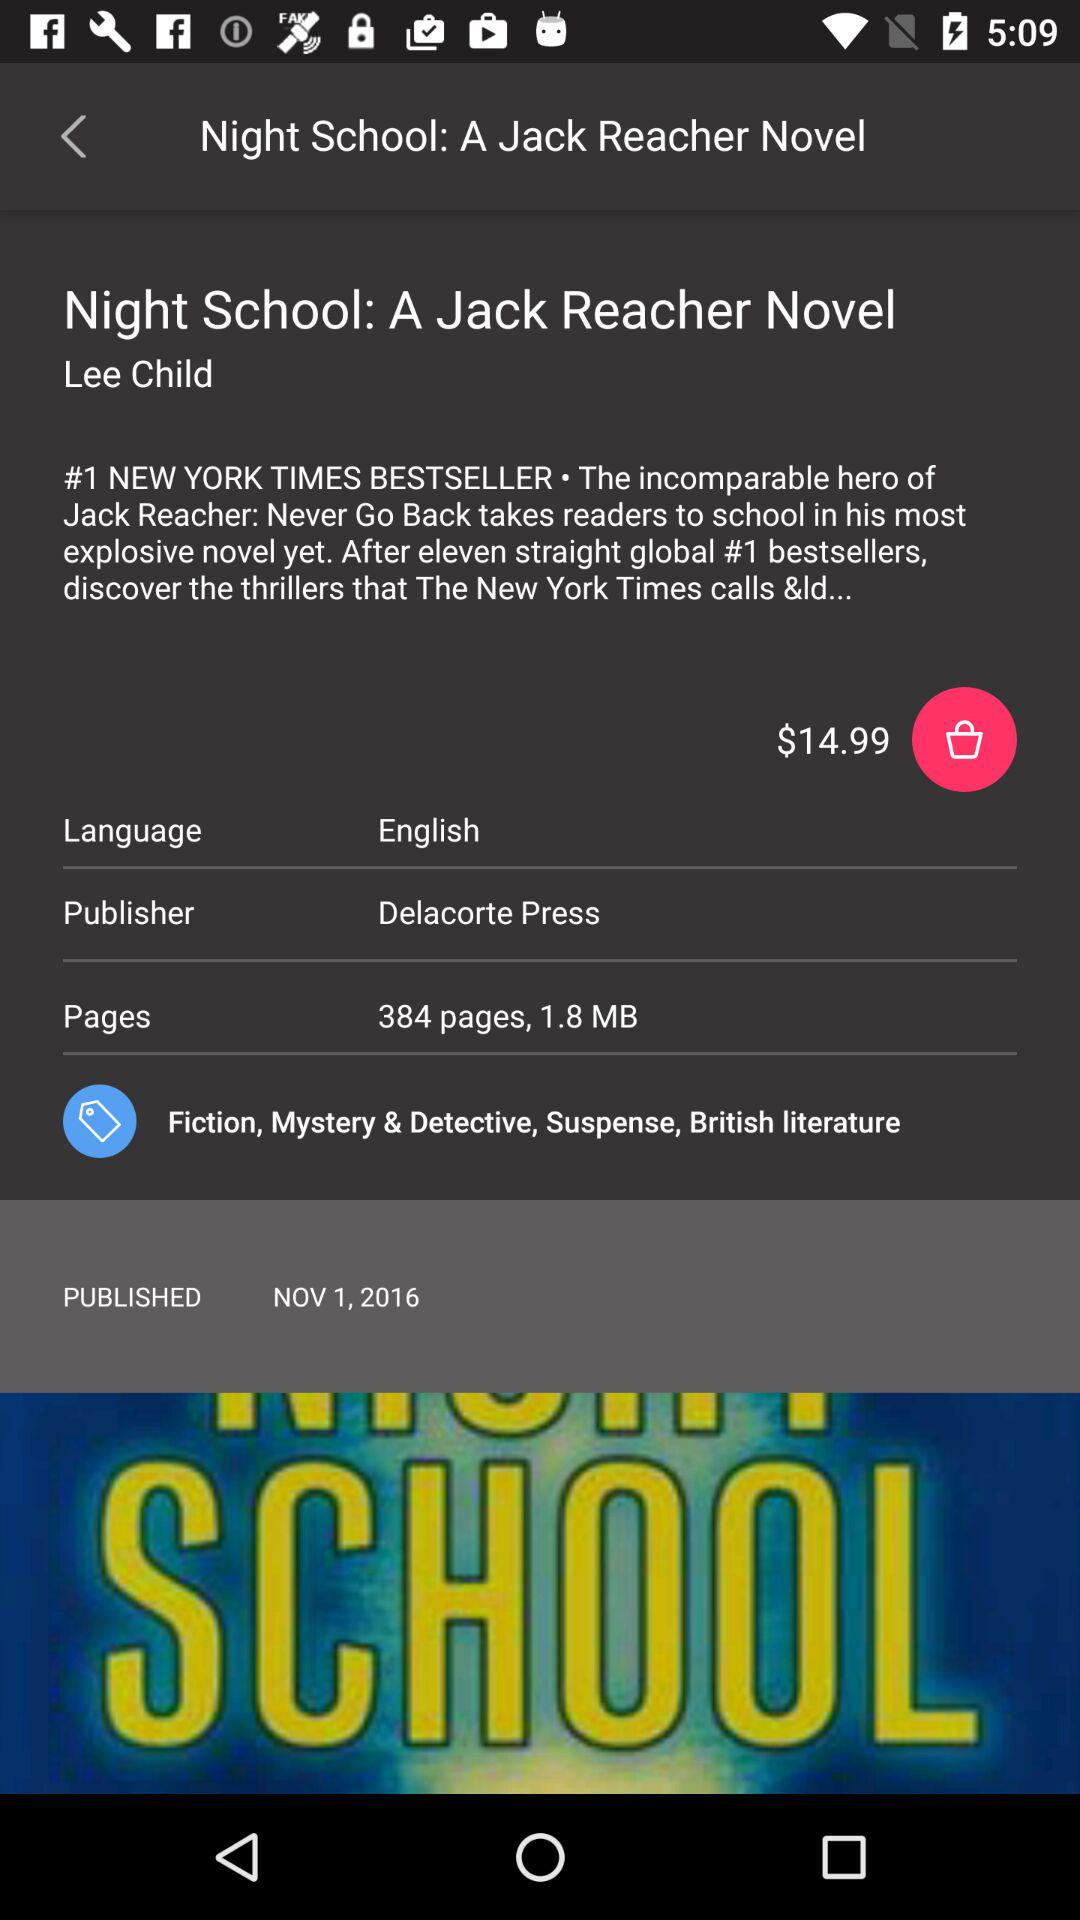What is the name of the novel? The name of the novel is "Night School: A Jack Reacher Novel". 